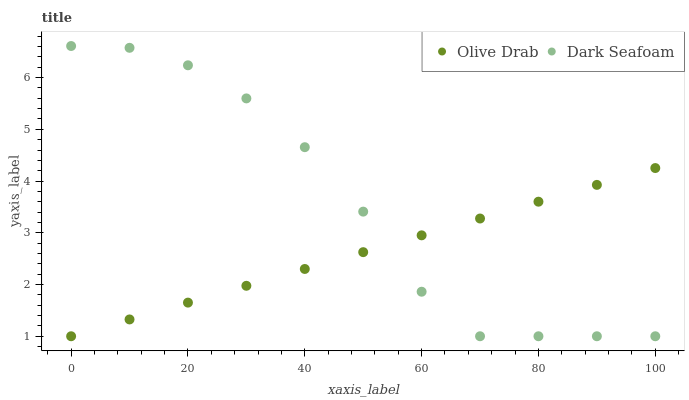Does Olive Drab have the minimum area under the curve?
Answer yes or no. Yes. Does Dark Seafoam have the maximum area under the curve?
Answer yes or no. Yes. Does Olive Drab have the maximum area under the curve?
Answer yes or no. No. Is Olive Drab the smoothest?
Answer yes or no. Yes. Is Dark Seafoam the roughest?
Answer yes or no. Yes. Is Olive Drab the roughest?
Answer yes or no. No. Does Dark Seafoam have the lowest value?
Answer yes or no. Yes. Does Dark Seafoam have the highest value?
Answer yes or no. Yes. Does Olive Drab have the highest value?
Answer yes or no. No. Does Olive Drab intersect Dark Seafoam?
Answer yes or no. Yes. Is Olive Drab less than Dark Seafoam?
Answer yes or no. No. Is Olive Drab greater than Dark Seafoam?
Answer yes or no. No. 